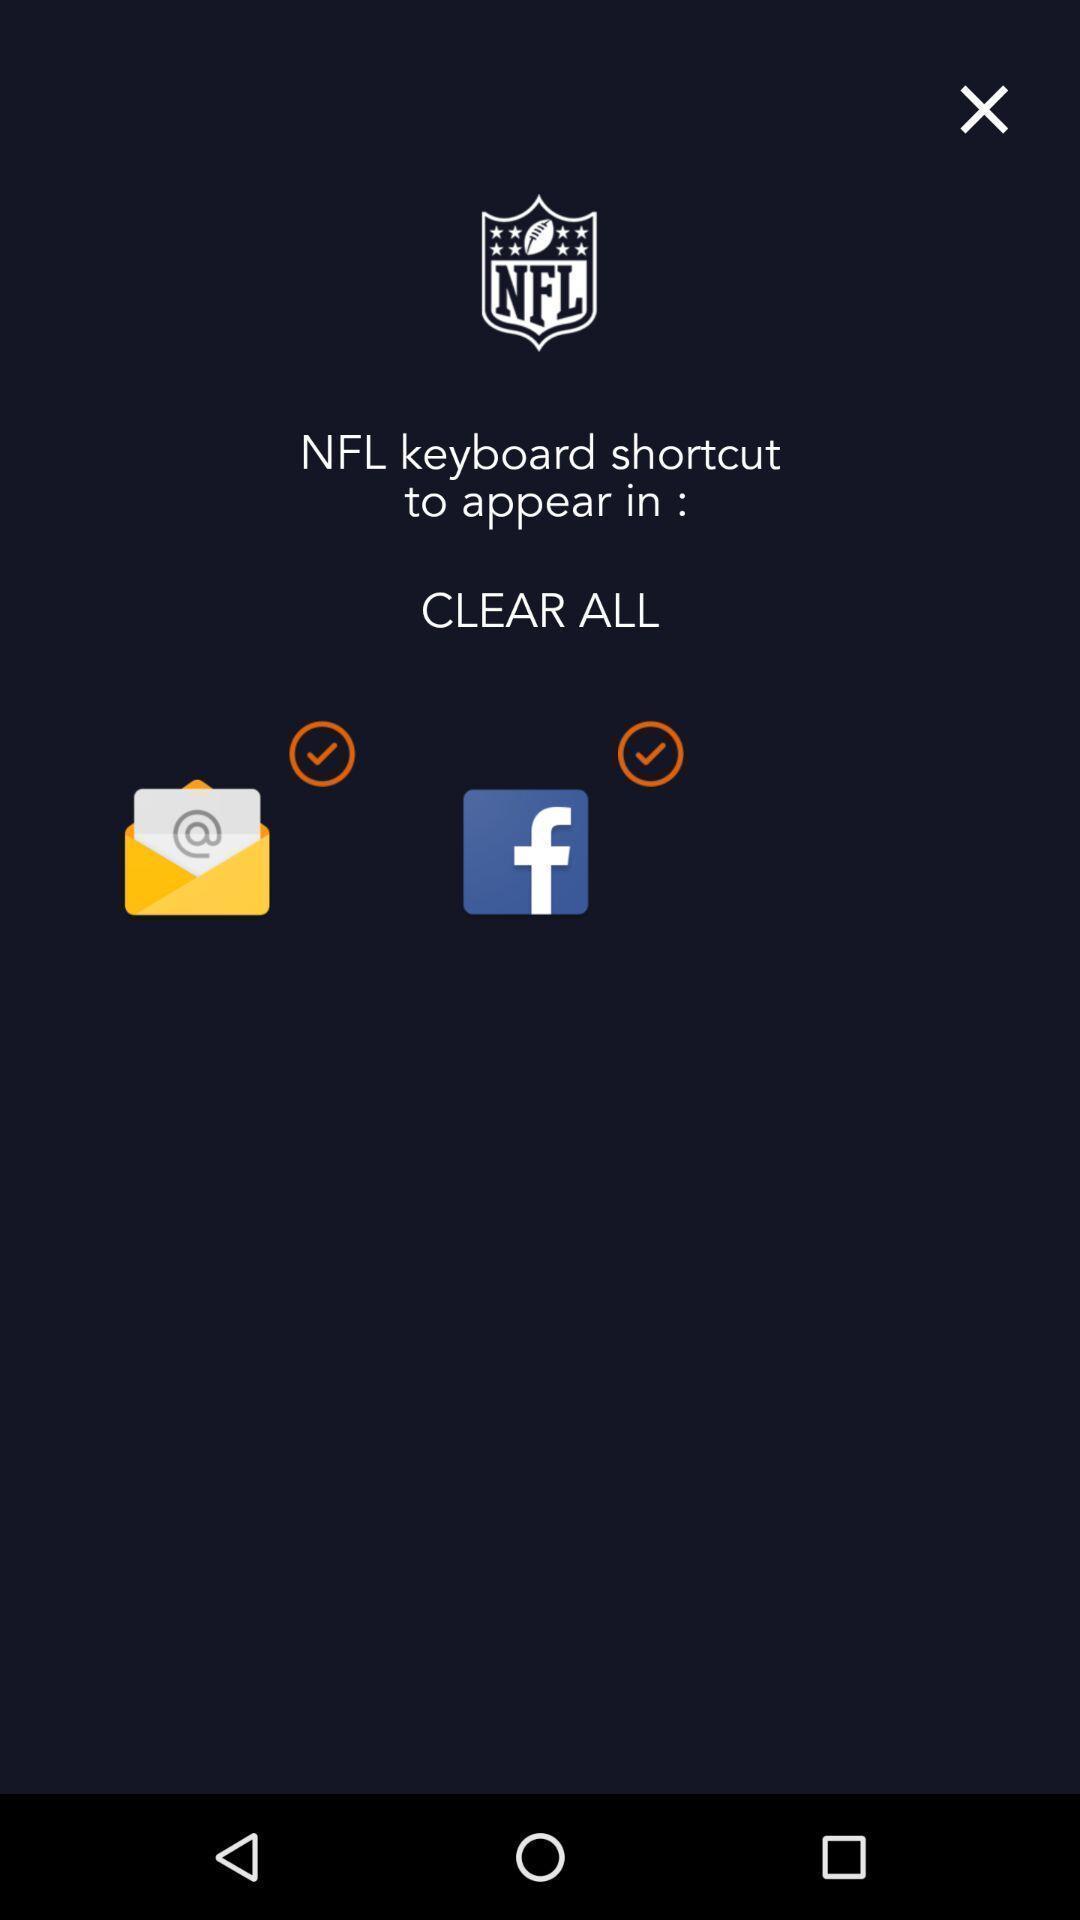Summarize the main components in this picture. Page showing preferences to keyboard shortcut. 